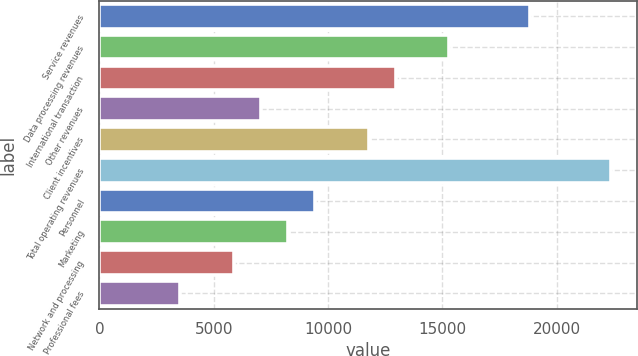Convert chart. <chart><loc_0><loc_0><loc_500><loc_500><bar_chart><fcel>Service revenues<fcel>Data processing revenues<fcel>International transaction<fcel>Other revenues<fcel>Client incentives<fcel>Total operating revenues<fcel>Personnel<fcel>Marketing<fcel>Network and processing<fcel>Professional fees<nl><fcel>18843<fcel>15310.5<fcel>12955.5<fcel>7068<fcel>11778<fcel>22375.5<fcel>9423<fcel>8245.5<fcel>5890.5<fcel>3535.5<nl></chart> 